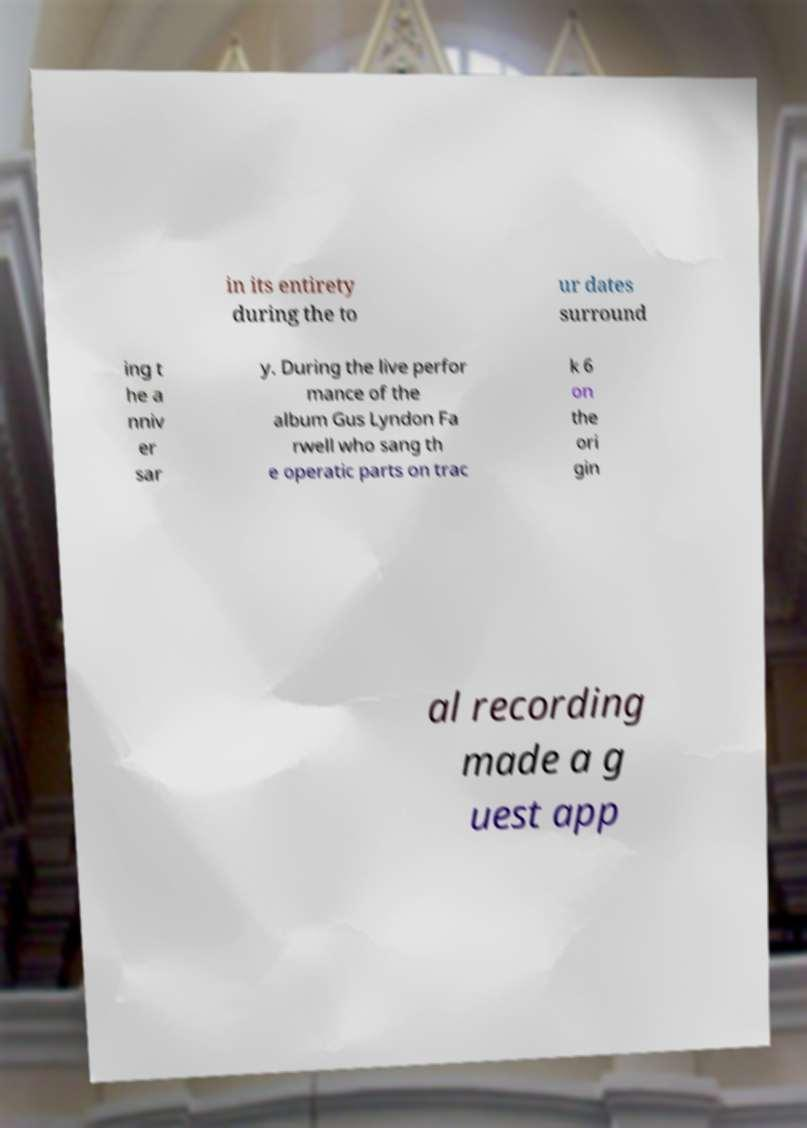I need the written content from this picture converted into text. Can you do that? in its entirety during the to ur dates surround ing t he a nniv er sar y. During the live perfor mance of the album Gus Lyndon Fa rwell who sang th e operatic parts on trac k 6 on the ori gin al recording made a g uest app 